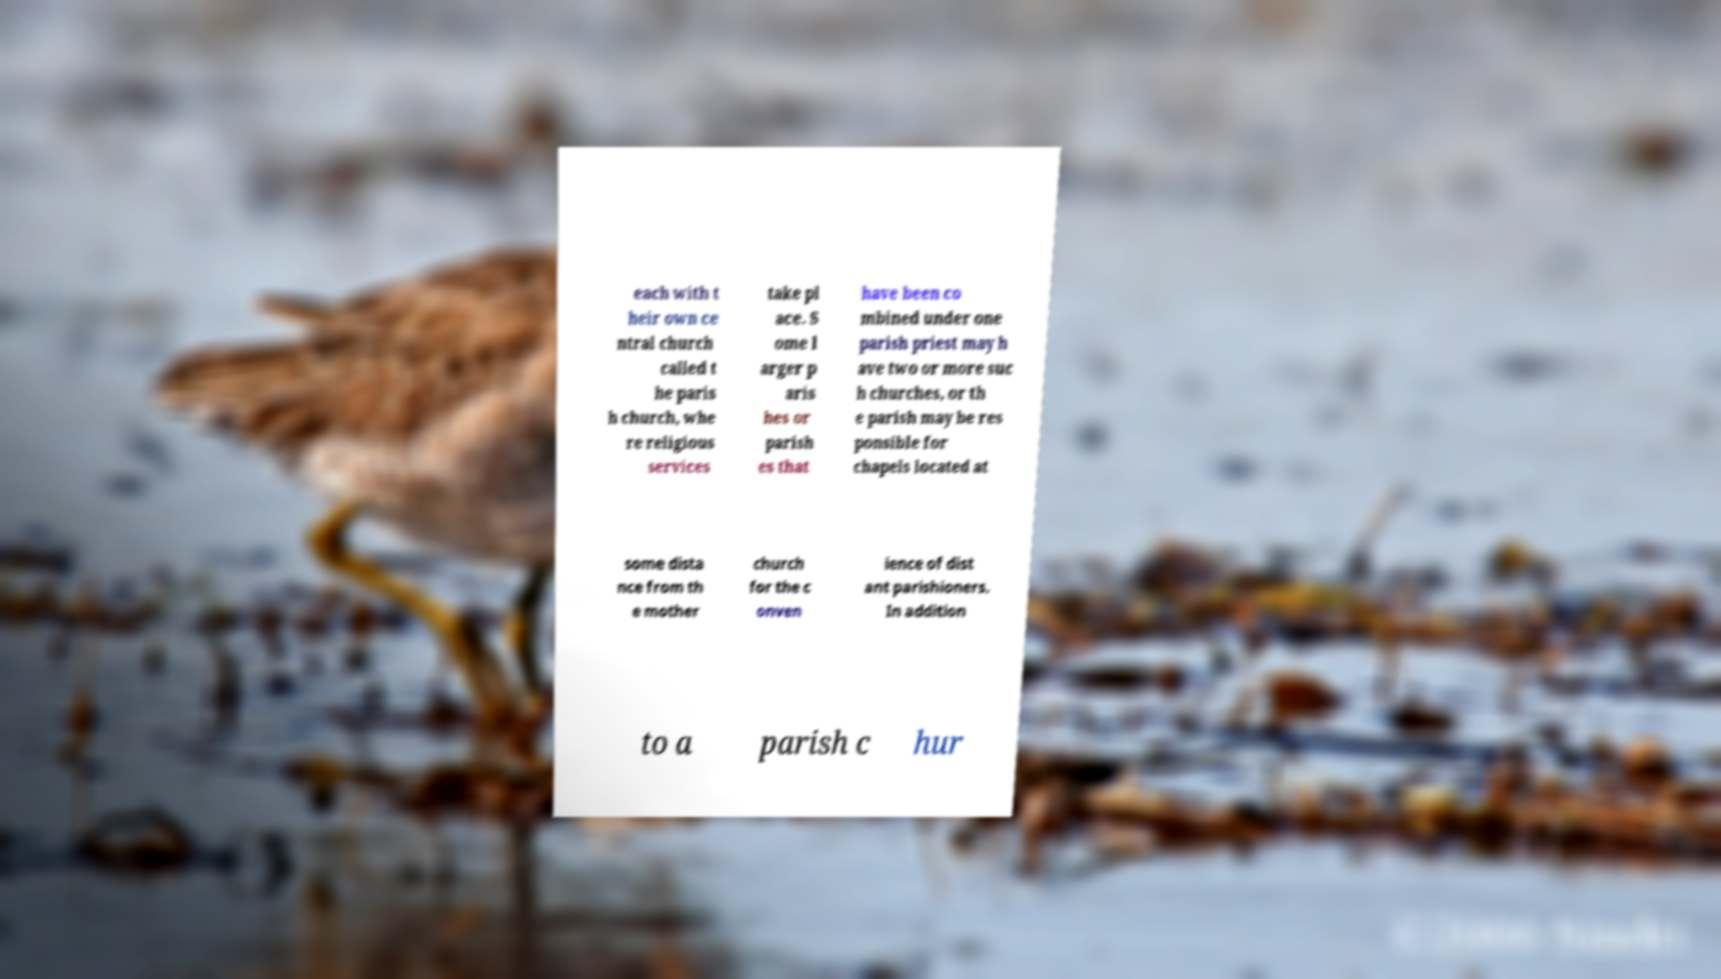Could you assist in decoding the text presented in this image and type it out clearly? each with t heir own ce ntral church called t he paris h church, whe re religious services take pl ace. S ome l arger p aris hes or parish es that have been co mbined under one parish priest may h ave two or more suc h churches, or th e parish may be res ponsible for chapels located at some dista nce from th e mother church for the c onven ience of dist ant parishioners. In addition to a parish c hur 